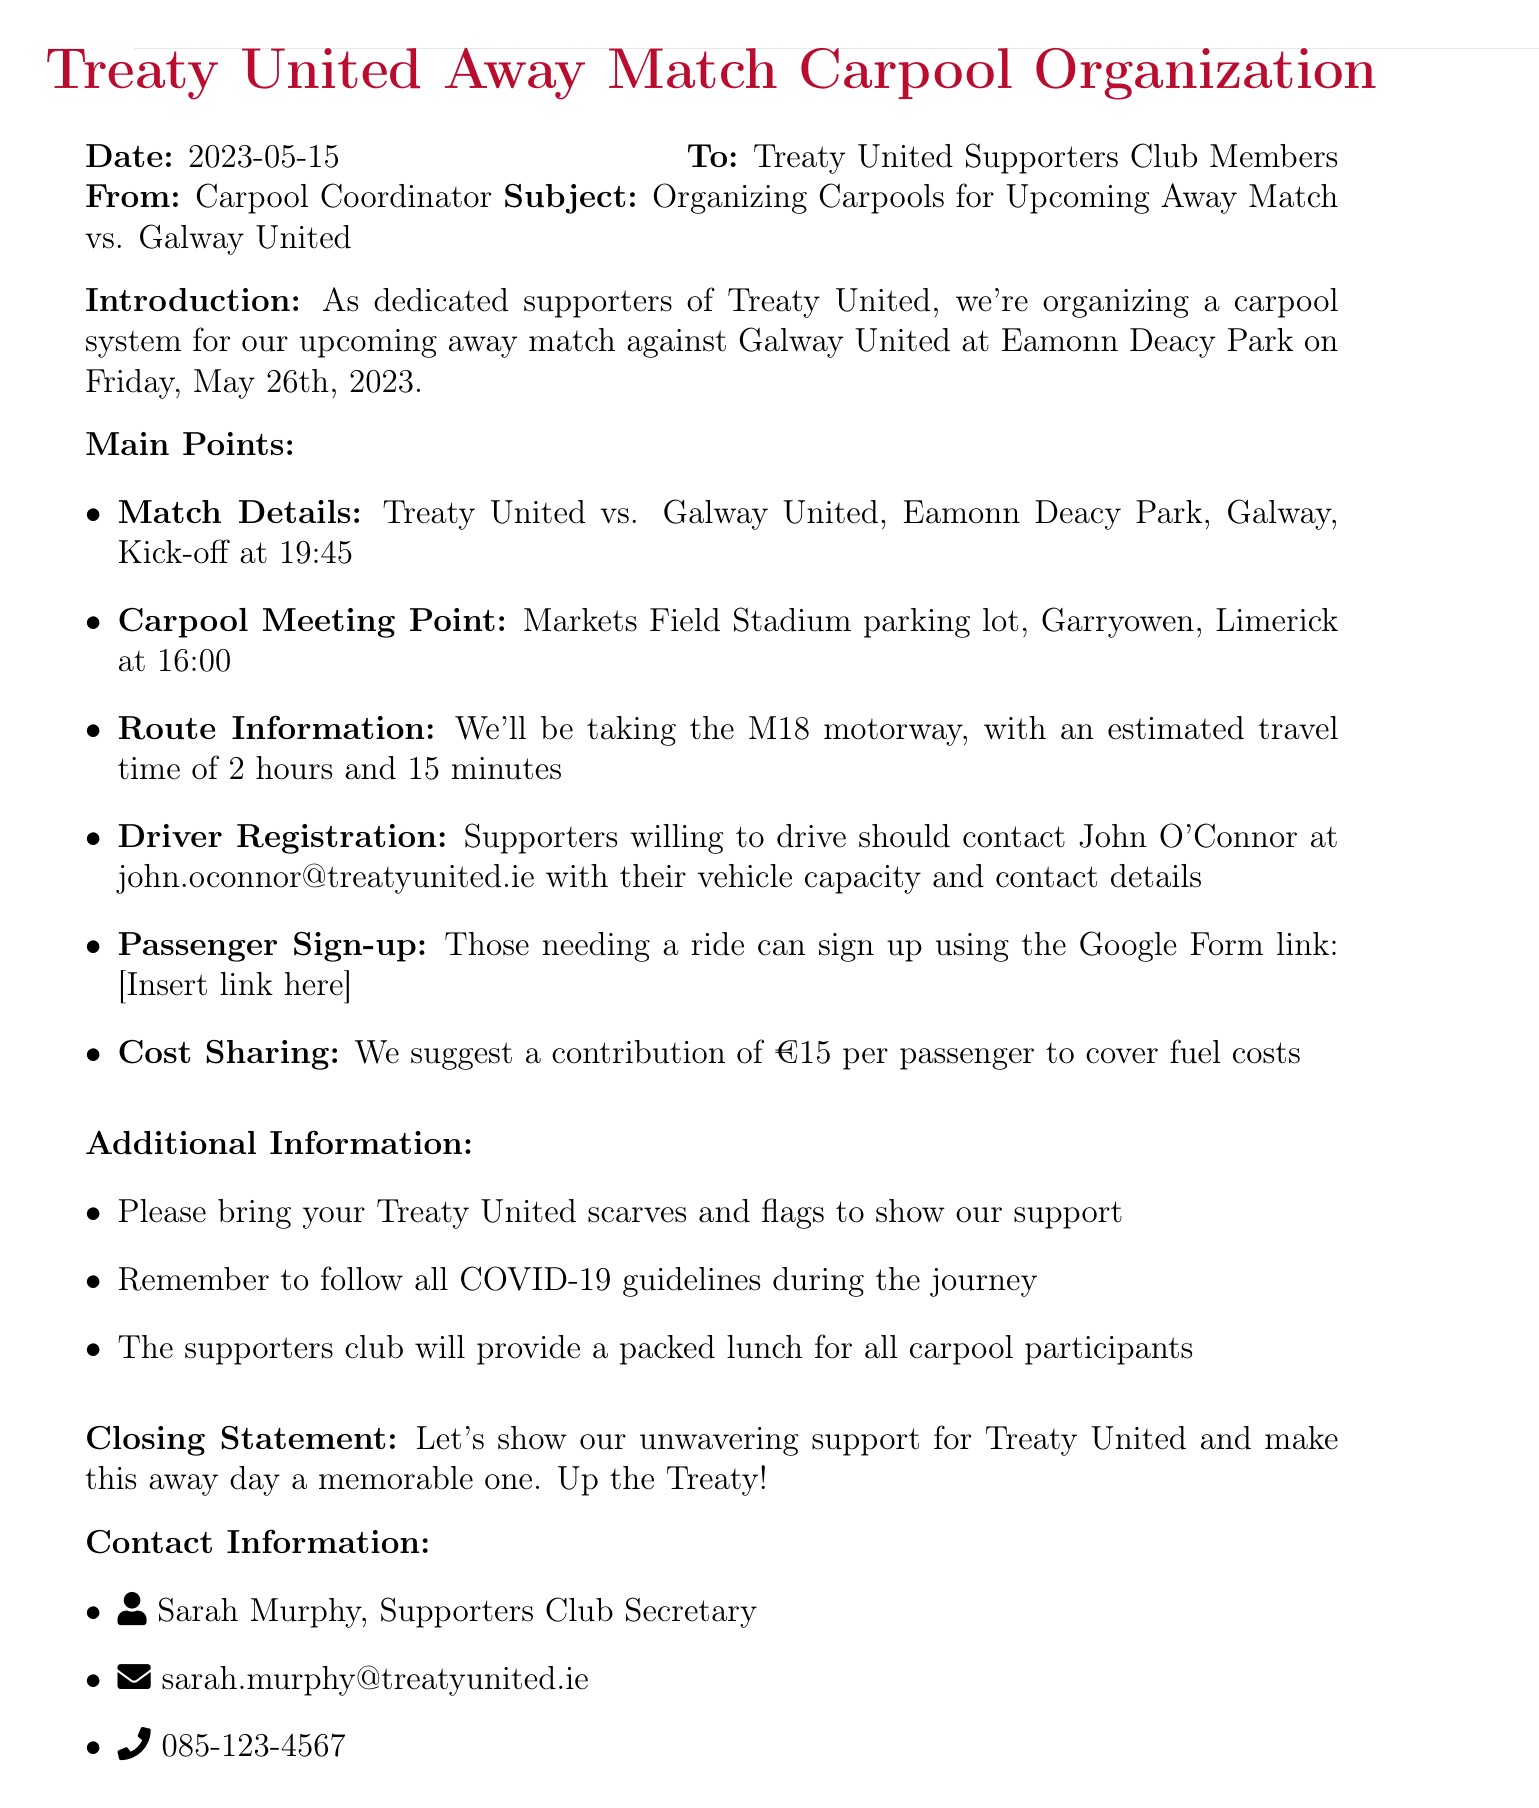What is the date of the memo? The date of the memo is stated at the beginning of the document.
Answer: 2023-05-15 What is the location of the match? The location of the match is mentioned in the main points section under "Match Details."
Answer: Eamonn Deacy Park What time should carpool participants meet? The meeting time is specified under "Carpool Meeting Point" in the main points section.
Answer: 16:00 Who should be contacted for driver registration? The name of the contact person for driver registration is provided in the "Driver Registration" point.
Answer: John O'Connor What is the estimated travel time to the match? The estimated travel time is outlined in the "Route Information" section of the memo.
Answer: 2 hours and 15 minutes What is the suggested contribution per passenger? The cost sharing amount is detailed in the "Cost Sharing" section.
Answer: €15 What is the purpose of bringing scarves and flags? The purpose is indicated in the "Additional Information" section of the memo.
Answer: To show support What will the supporters club provide for participants? This information is found in the "Additional Information" section regarding what is provided during the carpool.
Answer: Packed lunch 